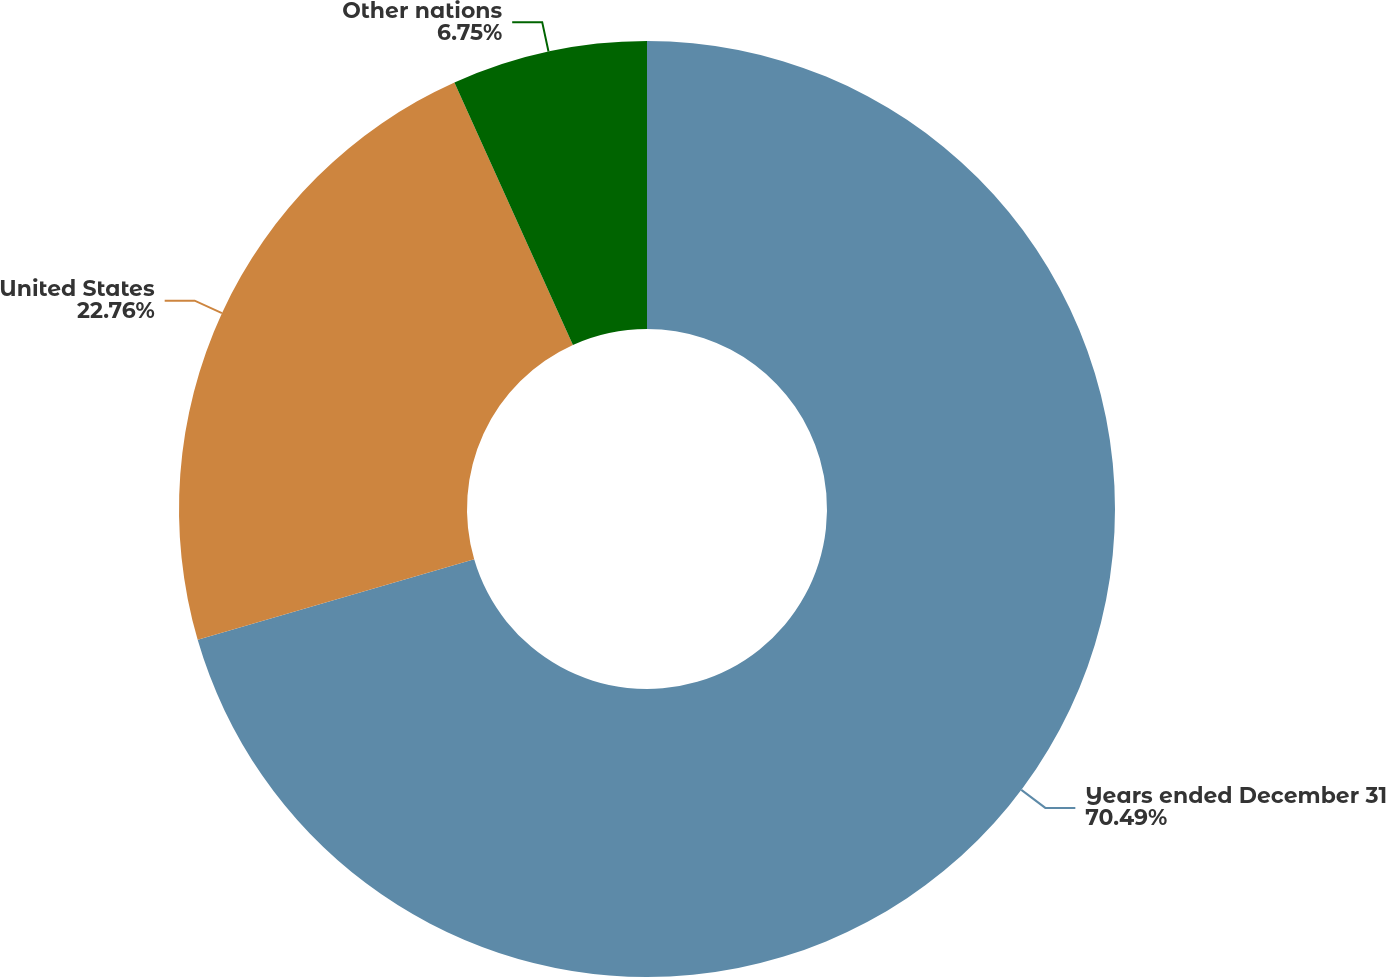Convert chart. <chart><loc_0><loc_0><loc_500><loc_500><pie_chart><fcel>Years ended December 31<fcel>United States<fcel>Other nations<nl><fcel>70.49%<fcel>22.76%<fcel>6.75%<nl></chart> 